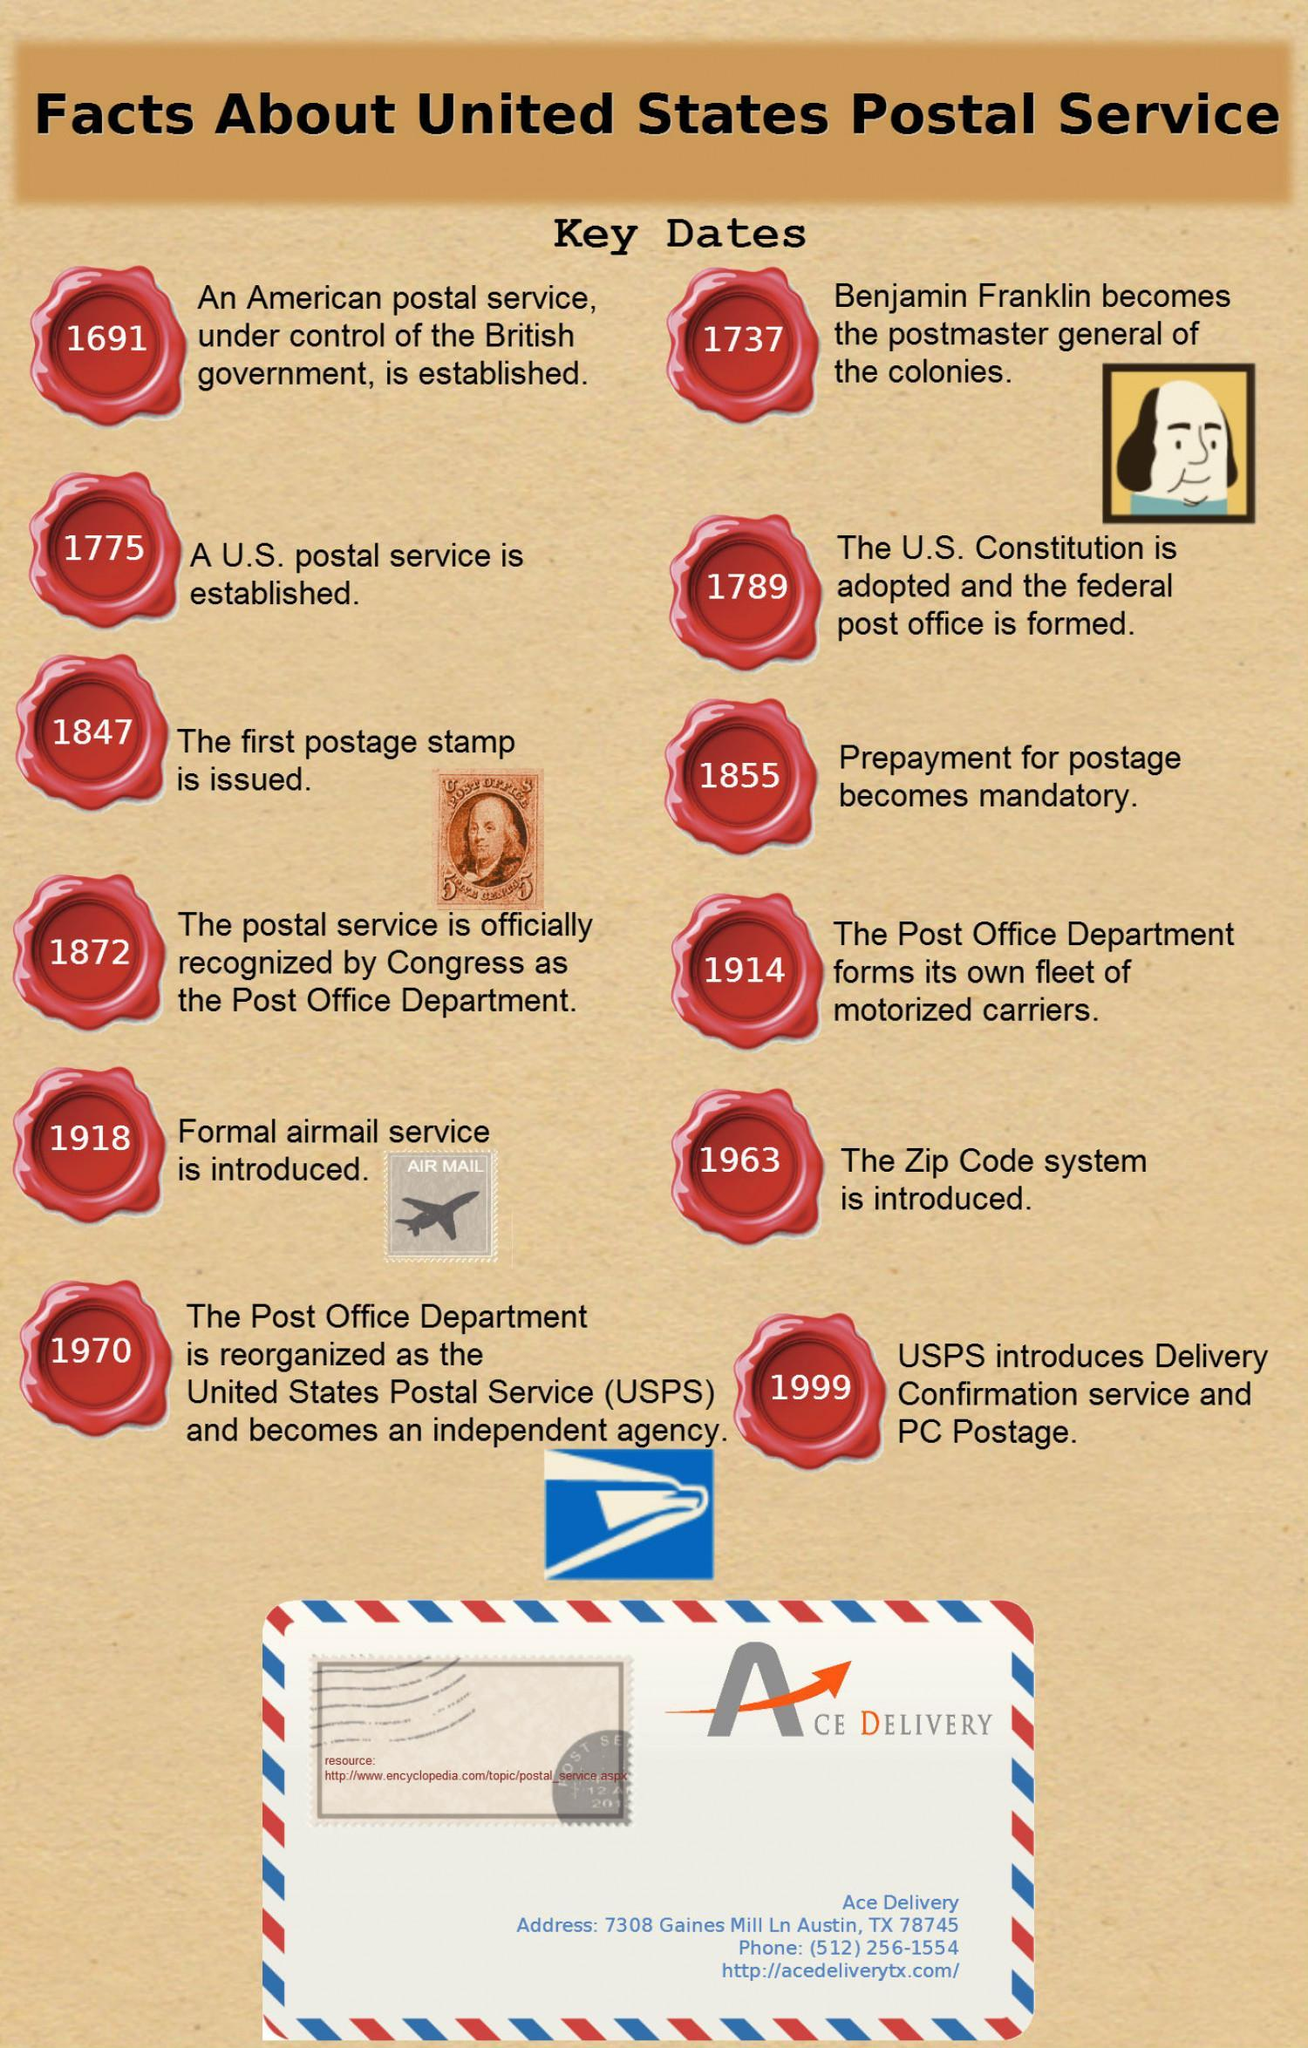Which system in the U.S postaI service  is introduced in 1963?
Answer the question with a short phrase. The Zip Code System When was the first postage stamp issued in the U.S.? 1847 Who beacame the postmaster generaI of the coIonies in the U.S. in 1737? Benjamin Franklin What service is introduced in the U.S. Post in the year 1918? Formal airmail service 